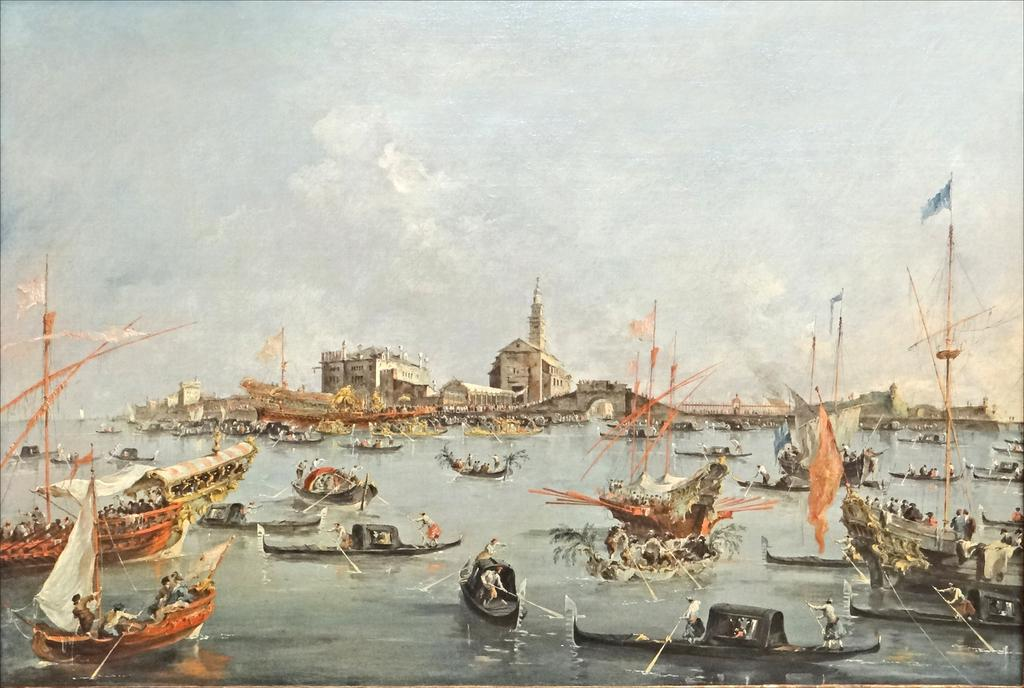What type of vehicles are in the image? There are boats with people sailing in the image. What structures can be seen in the image? There are buildings in the image. What decorative items are present in the image? There are flags in the image. What part of the natural environment is visible in the image? The sky is visible in the image. What type of jewel is being worn by the beast in the image? There is no beast or jewel present in the image. What type of pets are visible in the image? There are no pets visible in the image. 